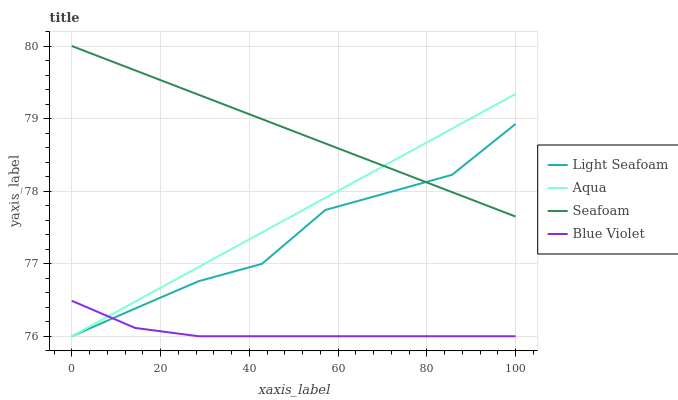Does Aqua have the minimum area under the curve?
Answer yes or no. No. Does Aqua have the maximum area under the curve?
Answer yes or no. No. Is Seafoam the smoothest?
Answer yes or no. No. Is Seafoam the roughest?
Answer yes or no. No. Does Seafoam have the lowest value?
Answer yes or no. No. Does Aqua have the highest value?
Answer yes or no. No. Is Blue Violet less than Seafoam?
Answer yes or no. Yes. Is Seafoam greater than Blue Violet?
Answer yes or no. Yes. Does Blue Violet intersect Seafoam?
Answer yes or no. No. 